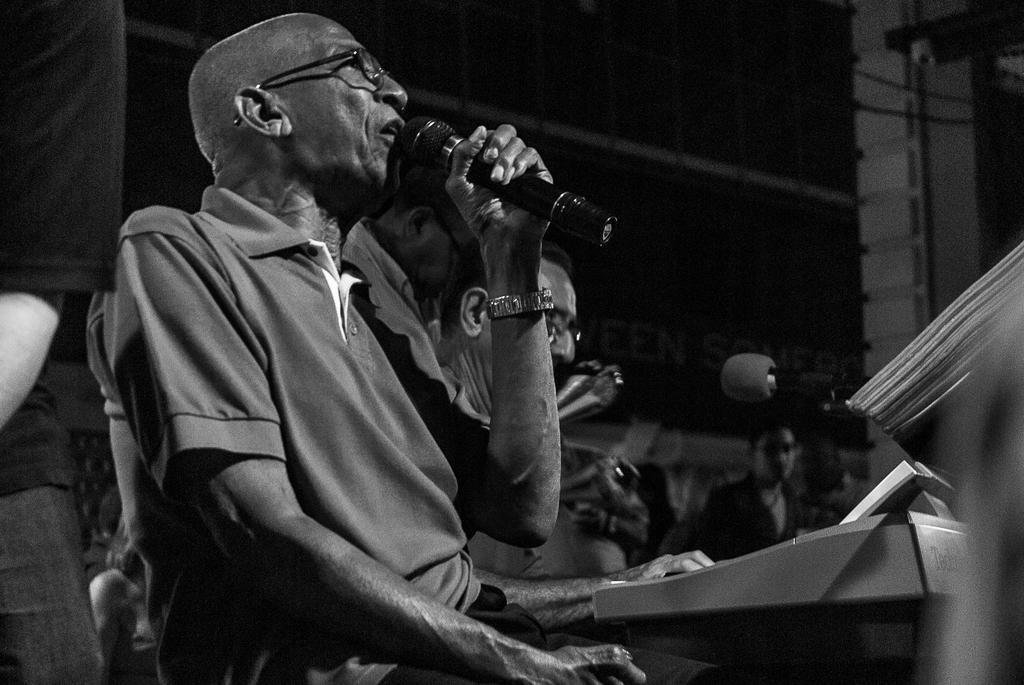In one or two sentences, can you explain what this image depicts? This is a black and white picture. Here we can see a man who is talking on the mike. And he has spectacles. 